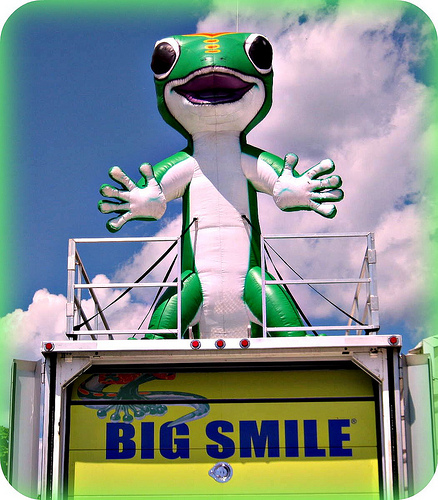<image>
Is there a sky behind the fence? Yes. From this viewpoint, the sky is positioned behind the fence, with the fence partially or fully occluding the sky. Is there a cloud above the lizard? Yes. The cloud is positioned above the lizard in the vertical space, higher up in the scene. 